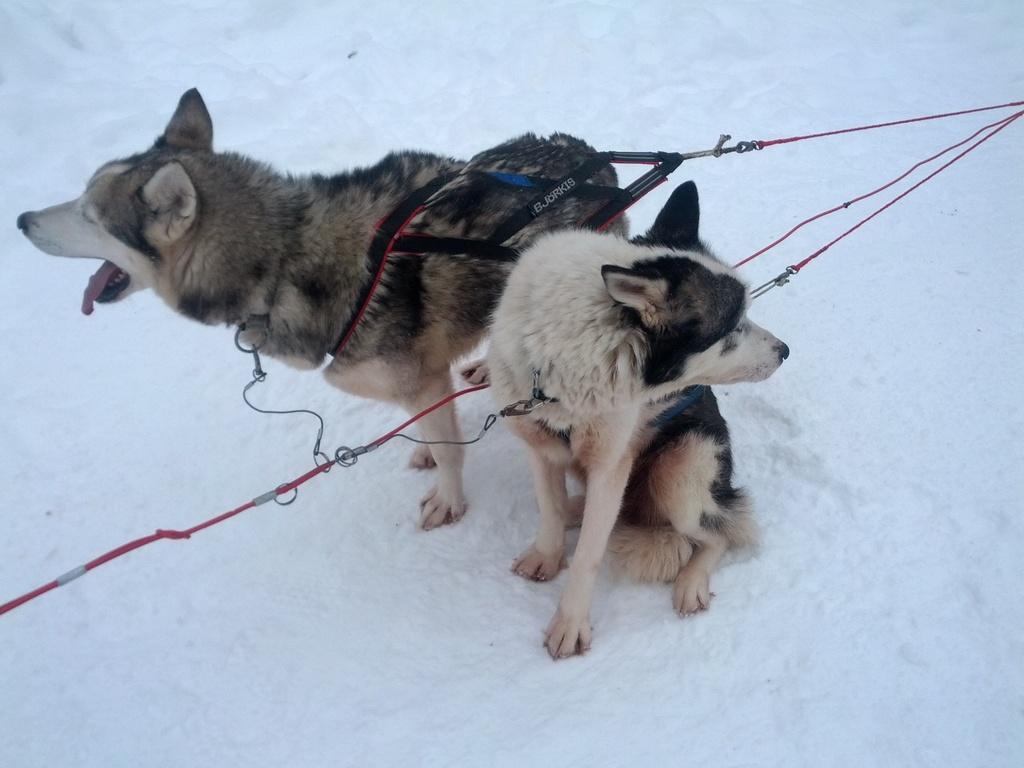In one or two sentences, can you explain what this image depicts? In the picture I can see two dogs in the snow. I can see the dog chains on the neck. 